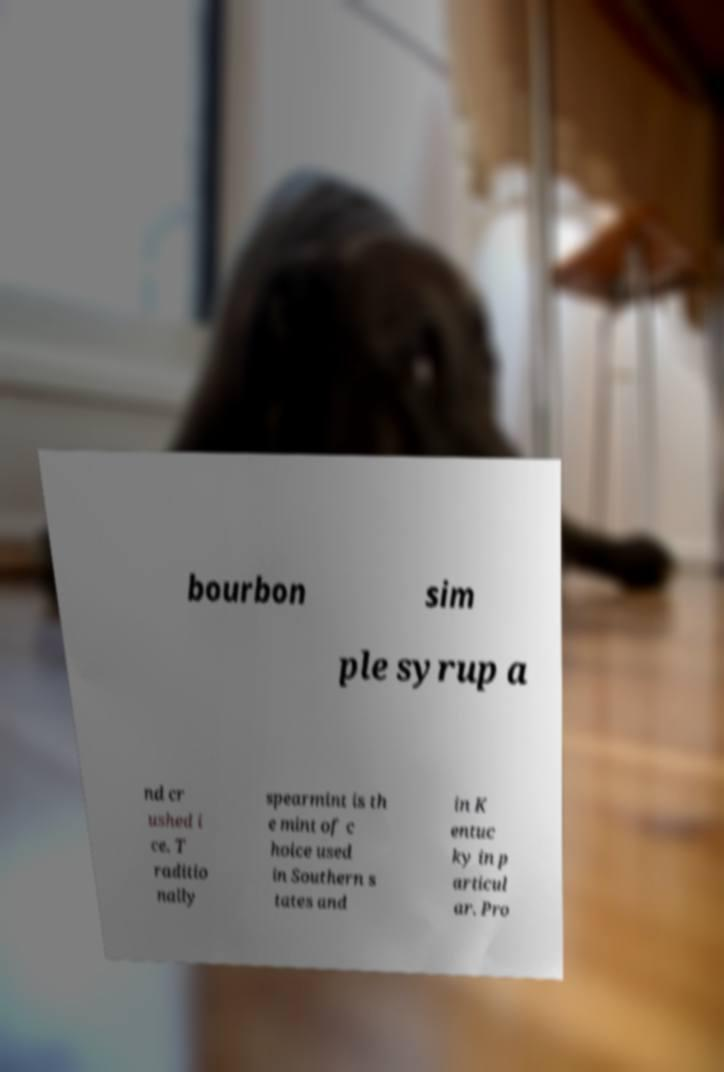Please read and relay the text visible in this image. What does it say? bourbon sim ple syrup a nd cr ushed i ce. T raditio nally spearmint is th e mint of c hoice used in Southern s tates and in K entuc ky in p articul ar. Pro 